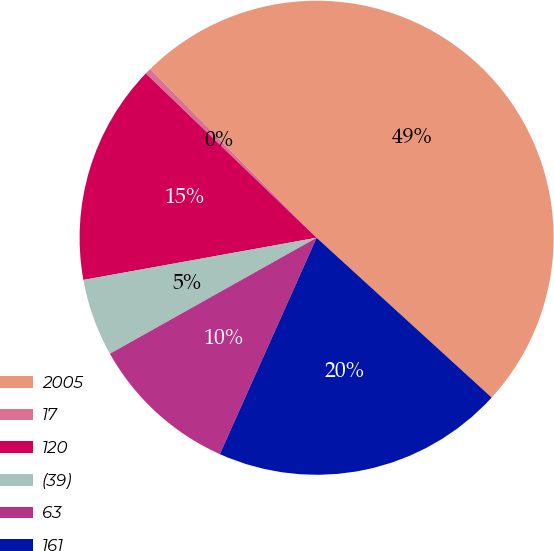Convert chart. <chart><loc_0><loc_0><loc_500><loc_500><pie_chart><fcel>2005<fcel>17<fcel>120<fcel>(39)<fcel>63<fcel>161<nl><fcel>49.17%<fcel>0.42%<fcel>15.04%<fcel>5.29%<fcel>10.17%<fcel>19.92%<nl></chart> 